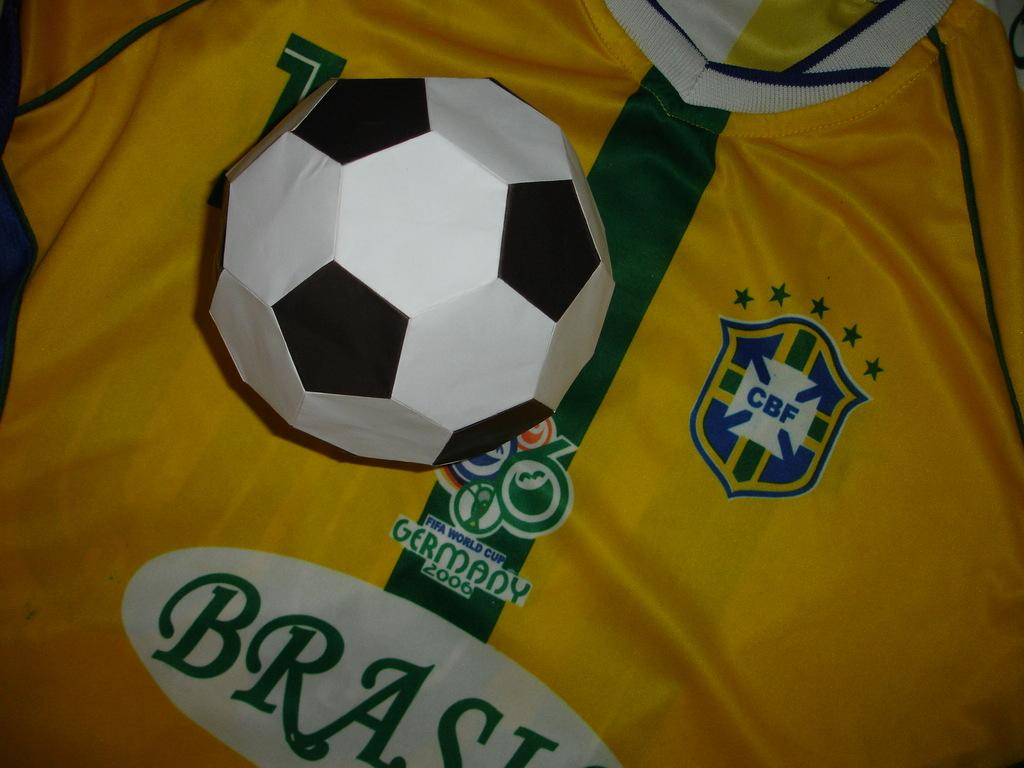Provide a one-sentence caption for the provided image. A paper soccer ball rests on a Brazilian jersey. 